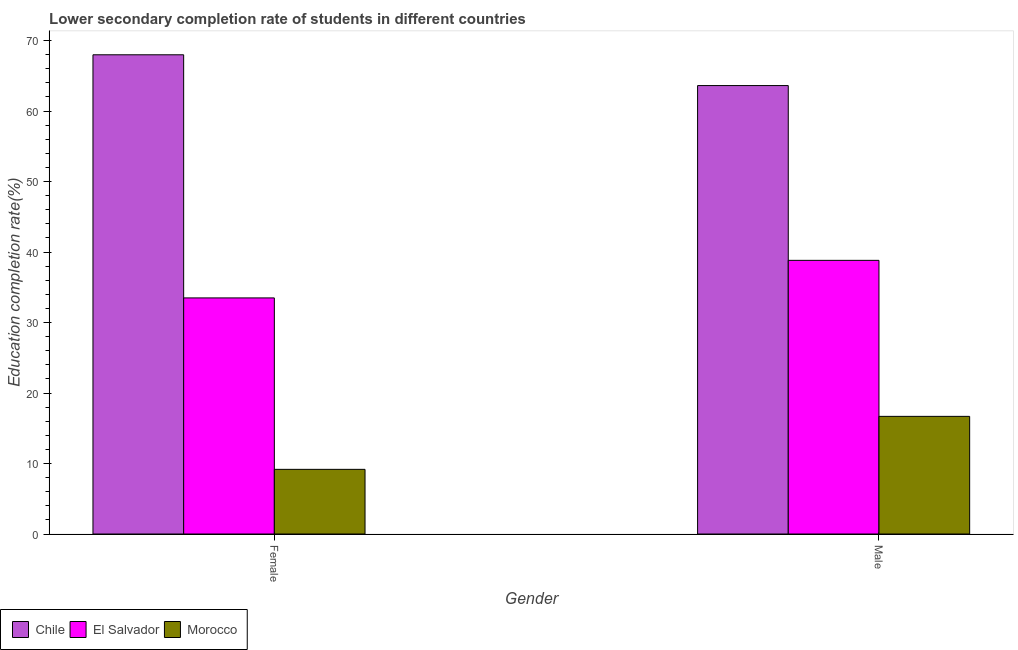How many groups of bars are there?
Keep it short and to the point. 2. Are the number of bars on each tick of the X-axis equal?
Provide a short and direct response. Yes. How many bars are there on the 1st tick from the left?
Provide a short and direct response. 3. How many bars are there on the 1st tick from the right?
Ensure brevity in your answer.  3. What is the education completion rate of male students in Chile?
Provide a short and direct response. 63.62. Across all countries, what is the maximum education completion rate of male students?
Ensure brevity in your answer.  63.62. Across all countries, what is the minimum education completion rate of female students?
Keep it short and to the point. 9.17. In which country was the education completion rate of male students maximum?
Make the answer very short. Chile. In which country was the education completion rate of female students minimum?
Give a very brief answer. Morocco. What is the total education completion rate of male students in the graph?
Provide a short and direct response. 119.13. What is the difference between the education completion rate of female students in Chile and that in El Salvador?
Your answer should be very brief. 34.49. What is the difference between the education completion rate of female students in Morocco and the education completion rate of male students in Chile?
Your answer should be very brief. -54.45. What is the average education completion rate of female students per country?
Give a very brief answer. 36.88. What is the difference between the education completion rate of male students and education completion rate of female students in El Salvador?
Offer a terse response. 5.33. What is the ratio of the education completion rate of male students in Morocco to that in El Salvador?
Give a very brief answer. 0.43. What does the 3rd bar from the left in Female represents?
Ensure brevity in your answer.  Morocco. What does the 1st bar from the right in Female represents?
Provide a short and direct response. Morocco. How many bars are there?
Offer a terse response. 6. Are all the bars in the graph horizontal?
Ensure brevity in your answer.  No. How many countries are there in the graph?
Keep it short and to the point. 3. Does the graph contain grids?
Make the answer very short. No. How many legend labels are there?
Provide a short and direct response. 3. How are the legend labels stacked?
Your response must be concise. Horizontal. What is the title of the graph?
Keep it short and to the point. Lower secondary completion rate of students in different countries. Does "Botswana" appear as one of the legend labels in the graph?
Offer a terse response. No. What is the label or title of the X-axis?
Your answer should be compact. Gender. What is the label or title of the Y-axis?
Keep it short and to the point. Education completion rate(%). What is the Education completion rate(%) of Chile in Female?
Keep it short and to the point. 67.99. What is the Education completion rate(%) of El Salvador in Female?
Provide a succinct answer. 33.49. What is the Education completion rate(%) of Morocco in Female?
Ensure brevity in your answer.  9.17. What is the Education completion rate(%) in Chile in Male?
Ensure brevity in your answer.  63.62. What is the Education completion rate(%) in El Salvador in Male?
Your response must be concise. 38.82. What is the Education completion rate(%) of Morocco in Male?
Your answer should be very brief. 16.69. Across all Gender, what is the maximum Education completion rate(%) in Chile?
Provide a short and direct response. 67.99. Across all Gender, what is the maximum Education completion rate(%) of El Salvador?
Offer a very short reply. 38.82. Across all Gender, what is the maximum Education completion rate(%) in Morocco?
Your answer should be very brief. 16.69. Across all Gender, what is the minimum Education completion rate(%) in Chile?
Provide a short and direct response. 63.62. Across all Gender, what is the minimum Education completion rate(%) of El Salvador?
Keep it short and to the point. 33.49. Across all Gender, what is the minimum Education completion rate(%) in Morocco?
Ensure brevity in your answer.  9.17. What is the total Education completion rate(%) in Chile in the graph?
Provide a short and direct response. 131.61. What is the total Education completion rate(%) of El Salvador in the graph?
Keep it short and to the point. 72.32. What is the total Education completion rate(%) of Morocco in the graph?
Your response must be concise. 25.86. What is the difference between the Education completion rate(%) of Chile in Female and that in Male?
Offer a very short reply. 4.37. What is the difference between the Education completion rate(%) of El Salvador in Female and that in Male?
Give a very brief answer. -5.33. What is the difference between the Education completion rate(%) of Morocco in Female and that in Male?
Provide a succinct answer. -7.52. What is the difference between the Education completion rate(%) of Chile in Female and the Education completion rate(%) of El Salvador in Male?
Offer a very short reply. 29.16. What is the difference between the Education completion rate(%) of Chile in Female and the Education completion rate(%) of Morocco in Male?
Offer a terse response. 51.3. What is the difference between the Education completion rate(%) of El Salvador in Female and the Education completion rate(%) of Morocco in Male?
Offer a terse response. 16.8. What is the average Education completion rate(%) in Chile per Gender?
Ensure brevity in your answer.  65.8. What is the average Education completion rate(%) of El Salvador per Gender?
Keep it short and to the point. 36.16. What is the average Education completion rate(%) in Morocco per Gender?
Give a very brief answer. 12.93. What is the difference between the Education completion rate(%) of Chile and Education completion rate(%) of El Salvador in Female?
Provide a short and direct response. 34.49. What is the difference between the Education completion rate(%) in Chile and Education completion rate(%) in Morocco in Female?
Ensure brevity in your answer.  58.81. What is the difference between the Education completion rate(%) of El Salvador and Education completion rate(%) of Morocco in Female?
Give a very brief answer. 24.32. What is the difference between the Education completion rate(%) in Chile and Education completion rate(%) in El Salvador in Male?
Provide a succinct answer. 24.8. What is the difference between the Education completion rate(%) in Chile and Education completion rate(%) in Morocco in Male?
Provide a short and direct response. 46.93. What is the difference between the Education completion rate(%) in El Salvador and Education completion rate(%) in Morocco in Male?
Your response must be concise. 22.13. What is the ratio of the Education completion rate(%) of Chile in Female to that in Male?
Keep it short and to the point. 1.07. What is the ratio of the Education completion rate(%) in El Salvador in Female to that in Male?
Keep it short and to the point. 0.86. What is the ratio of the Education completion rate(%) in Morocco in Female to that in Male?
Your response must be concise. 0.55. What is the difference between the highest and the second highest Education completion rate(%) in Chile?
Make the answer very short. 4.37. What is the difference between the highest and the second highest Education completion rate(%) of El Salvador?
Make the answer very short. 5.33. What is the difference between the highest and the second highest Education completion rate(%) of Morocco?
Ensure brevity in your answer.  7.52. What is the difference between the highest and the lowest Education completion rate(%) in Chile?
Offer a very short reply. 4.37. What is the difference between the highest and the lowest Education completion rate(%) of El Salvador?
Provide a short and direct response. 5.33. What is the difference between the highest and the lowest Education completion rate(%) of Morocco?
Make the answer very short. 7.52. 